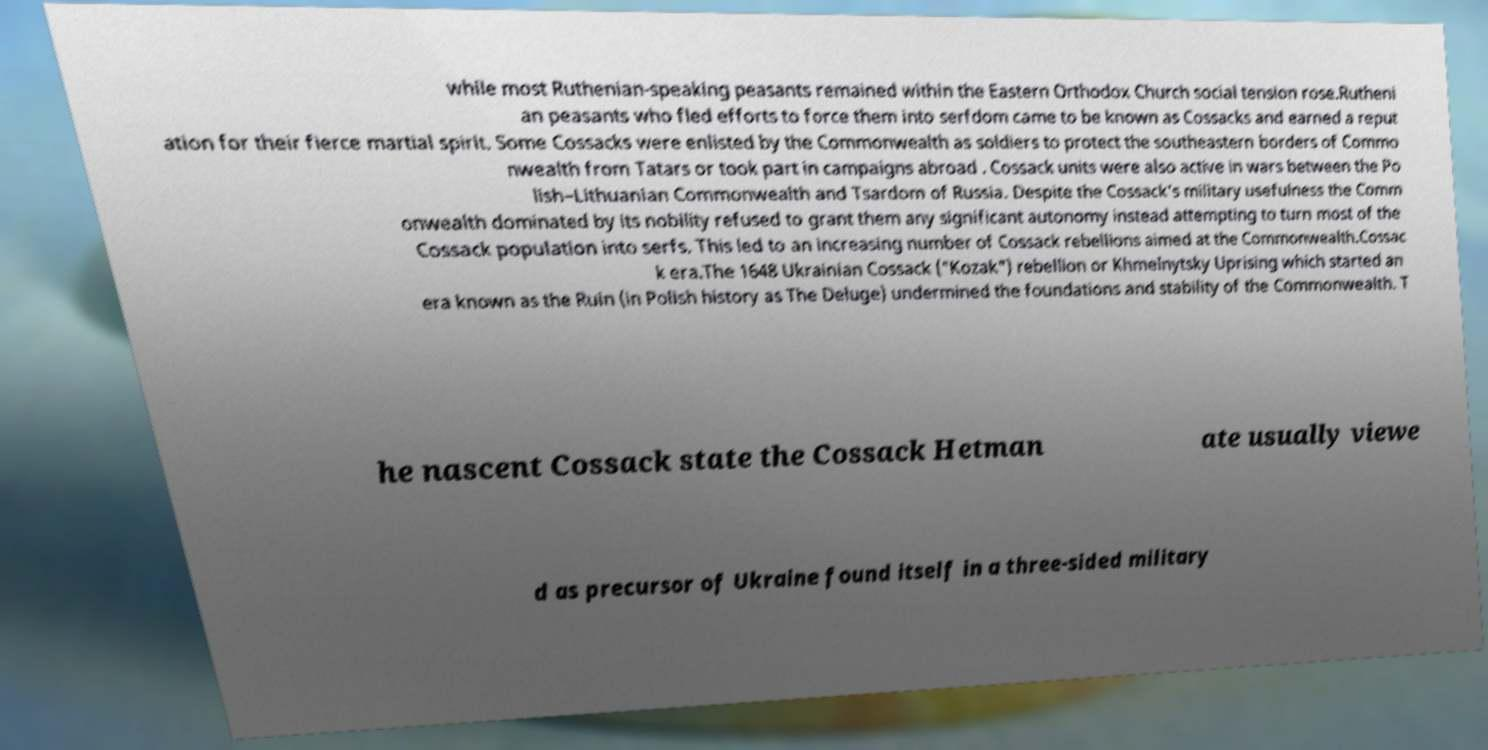There's text embedded in this image that I need extracted. Can you transcribe it verbatim? while most Ruthenian-speaking peasants remained within the Eastern Orthodox Church social tension rose.Rutheni an peasants who fled efforts to force them into serfdom came to be known as Cossacks and earned a reput ation for their fierce martial spirit. Some Cossacks were enlisted by the Commonwealth as soldiers to protect the southeastern borders of Commo nwealth from Tatars or took part in campaigns abroad . Cossack units were also active in wars between the Po lish–Lithuanian Commonwealth and Tsardom of Russia. Despite the Cossack's military usefulness the Comm onwealth dominated by its nobility refused to grant them any significant autonomy instead attempting to turn most of the Cossack population into serfs. This led to an increasing number of Cossack rebellions aimed at the Commonwealth.Cossac k era.The 1648 Ukrainian Cossack ("Kozak") rebellion or Khmelnytsky Uprising which started an era known as the Ruin (in Polish history as The Deluge) undermined the foundations and stability of the Commonwealth. T he nascent Cossack state the Cossack Hetman ate usually viewe d as precursor of Ukraine found itself in a three-sided military 